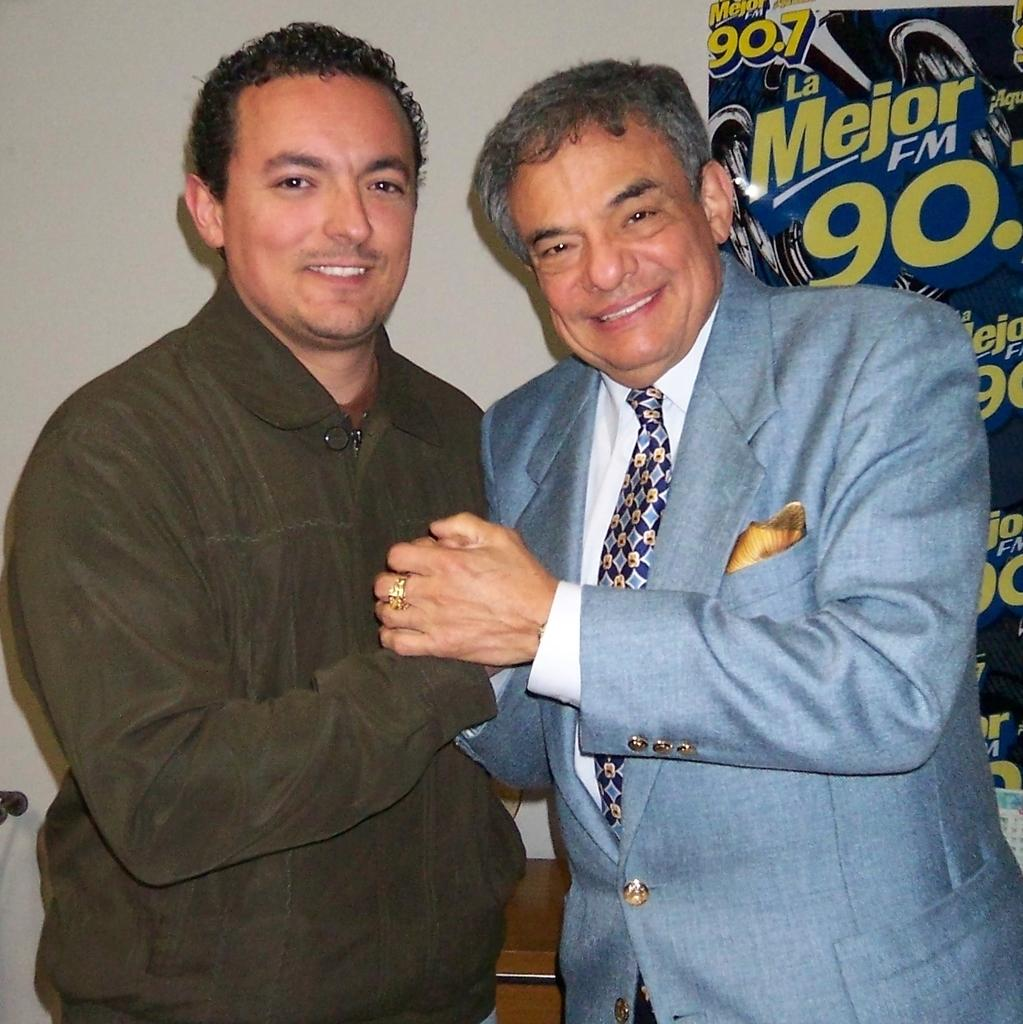What are the people in the image doing? The people in the image are standing, smiling, and holding hands. What can be seen in the background of the image? There is a board and a wall in the background of the image. What is located at the bottom of the image? There is a stand at the bottom of the image. What type of jewel can be seen on the board in the image? There is no jewel present on the board in the image. How many rolls are visible on the stand at the bottom of the image? There are no rolls visible on the stand at the bottom of the image. 